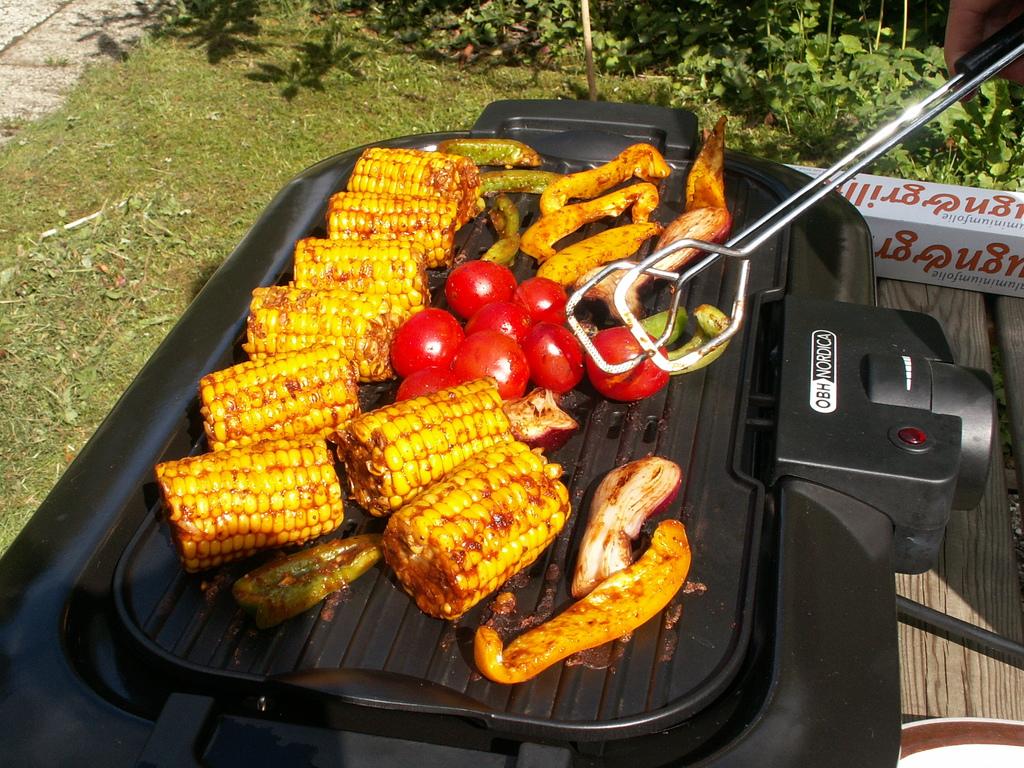What is the yellow big thing they are cooking?
Offer a very short reply. Answering does not require reading text in the image. 